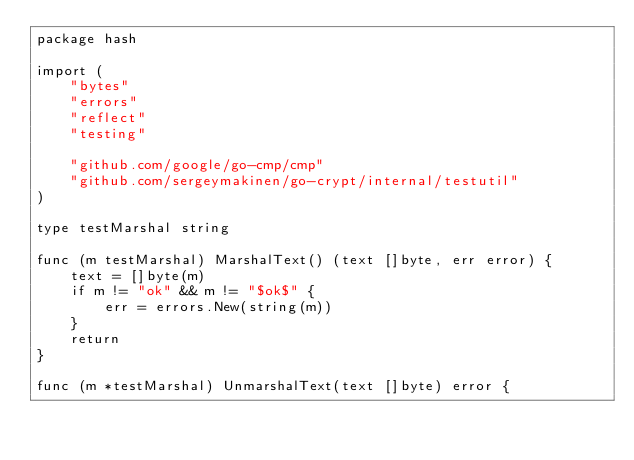<code> <loc_0><loc_0><loc_500><loc_500><_Go_>package hash

import (
	"bytes"
	"errors"
	"reflect"
	"testing"

	"github.com/google/go-cmp/cmp"
	"github.com/sergeymakinen/go-crypt/internal/testutil"
)

type testMarshal string

func (m testMarshal) MarshalText() (text []byte, err error) {
	text = []byte(m)
	if m != "ok" && m != "$ok$" {
		err = errors.New(string(m))
	}
	return
}

func (m *testMarshal) UnmarshalText(text []byte) error {</code> 